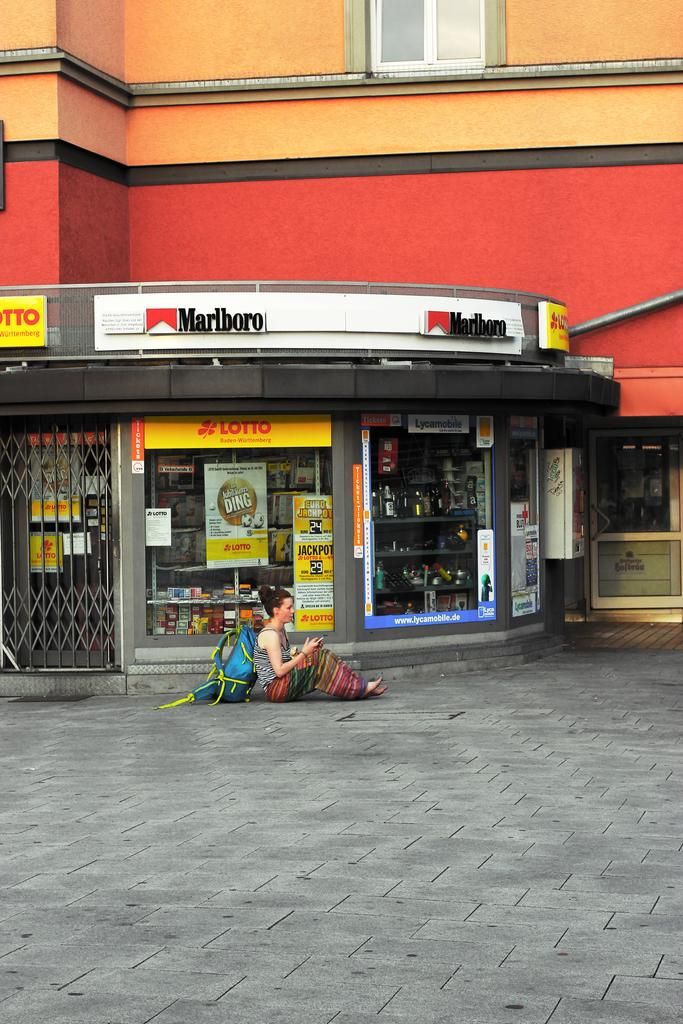<image>
Present a compact description of the photo's key features. A woman sits on the pavement with a large backpack in front of a closed store that sells cigarettes and Lotto. 